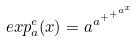Convert formula to latex. <formula><loc_0><loc_0><loc_500><loc_500>e x p _ { a } ^ { e } ( x ) = a ^ { a ^ { + ^ { + ^ { a ^ { x } } } } }</formula> 